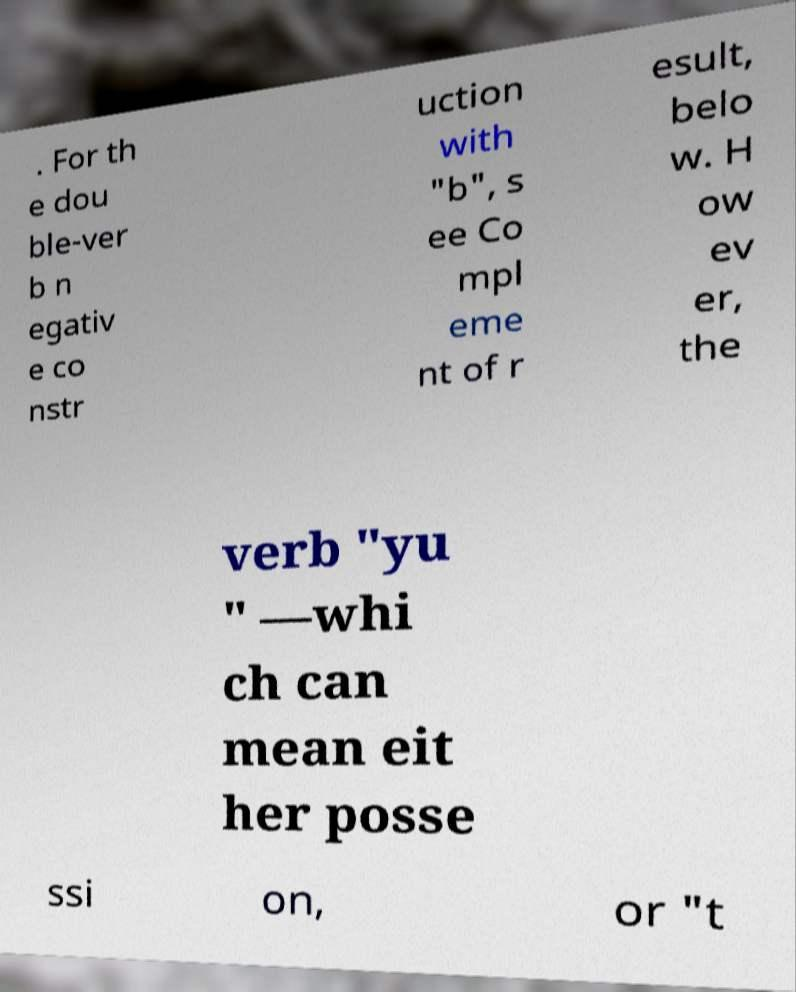Please read and relay the text visible in this image. What does it say? . For th e dou ble-ver b n egativ e co nstr uction with "b", s ee Co mpl eme nt of r esult, belo w. H ow ev er, the verb "yu " —whi ch can mean eit her posse ssi on, or "t 